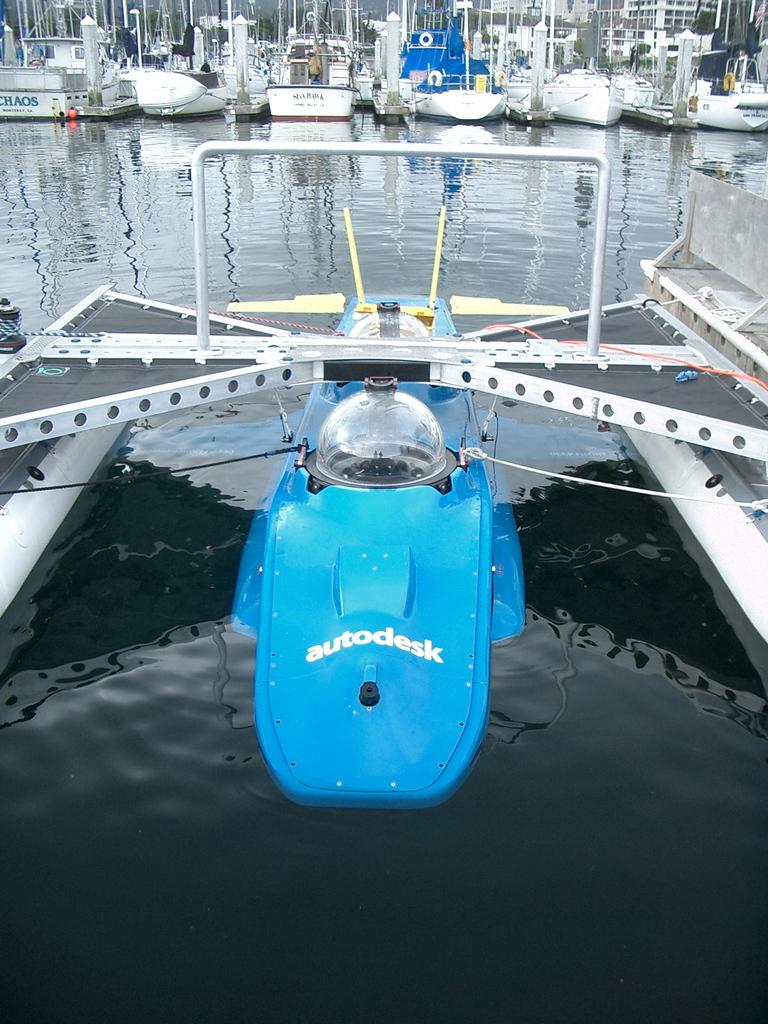What brand is the blue device?
Provide a short and direct response. Autodesk. 